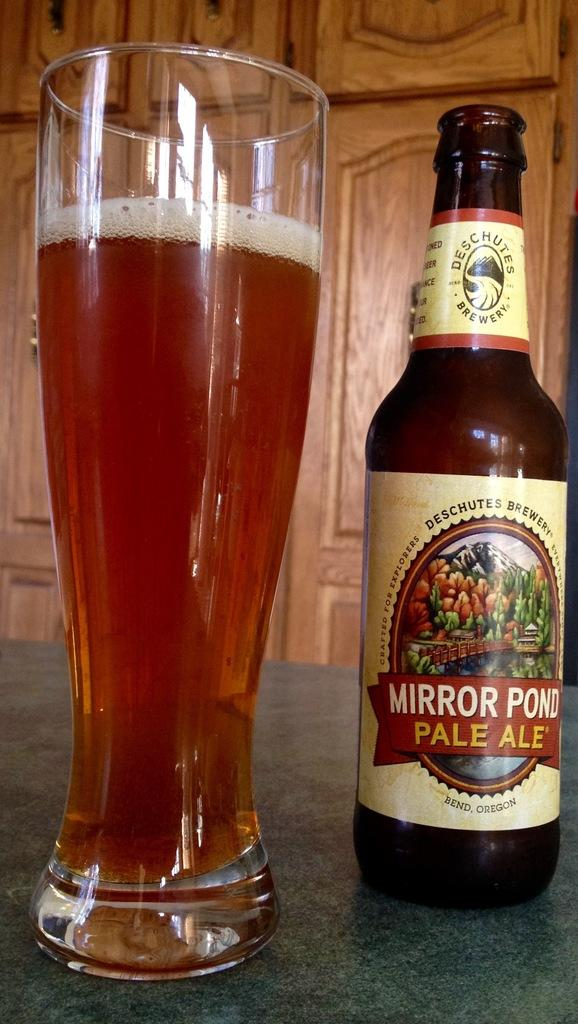<image>
Share a concise interpretation of the image provided. A bottle of beer is labeled Mirror Pond Pale Ale. 